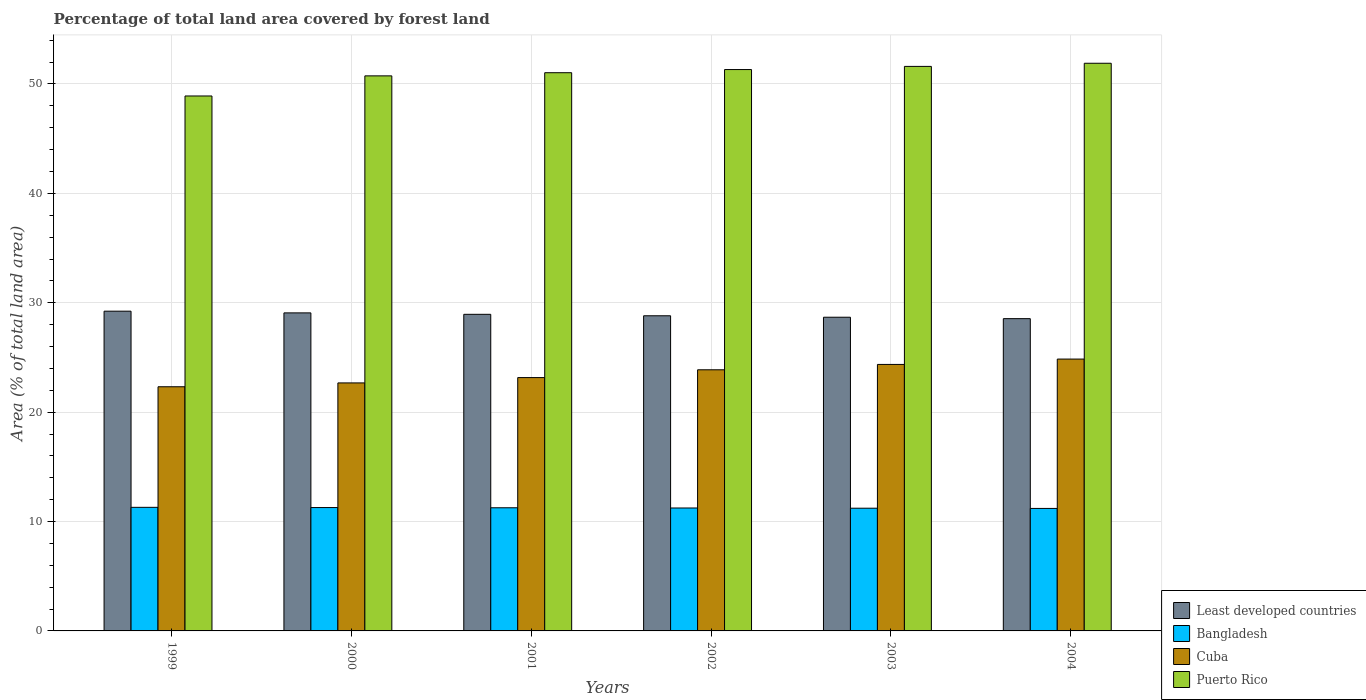Are the number of bars per tick equal to the number of legend labels?
Offer a very short reply. Yes. How many bars are there on the 4th tick from the right?
Your answer should be compact. 4. What is the percentage of forest land in Bangladesh in 2003?
Make the answer very short. 11.22. Across all years, what is the maximum percentage of forest land in Bangladesh?
Your answer should be compact. 11.3. Across all years, what is the minimum percentage of forest land in Least developed countries?
Your response must be concise. 28.55. In which year was the percentage of forest land in Bangladesh maximum?
Provide a short and direct response. 1999. In which year was the percentage of forest land in Bangladesh minimum?
Provide a short and direct response. 2004. What is the total percentage of forest land in Cuba in the graph?
Provide a short and direct response. 141.24. What is the difference between the percentage of forest land in Puerto Rico in 1999 and that in 2000?
Keep it short and to the point. -1.84. What is the difference between the percentage of forest land in Least developed countries in 2001 and the percentage of forest land in Cuba in 1999?
Your answer should be very brief. 6.62. What is the average percentage of forest land in Bangladesh per year?
Offer a terse response. 11.25. In the year 2000, what is the difference between the percentage of forest land in Bangladesh and percentage of forest land in Least developed countries?
Provide a succinct answer. -17.8. What is the ratio of the percentage of forest land in Puerto Rico in 2002 to that in 2004?
Provide a succinct answer. 0.99. Is the percentage of forest land in Puerto Rico in 1999 less than that in 2004?
Your response must be concise. Yes. What is the difference between the highest and the second highest percentage of forest land in Bangladesh?
Offer a very short reply. 0.02. What is the difference between the highest and the lowest percentage of forest land in Bangladesh?
Provide a succinct answer. 0.1. In how many years, is the percentage of forest land in Least developed countries greater than the average percentage of forest land in Least developed countries taken over all years?
Provide a succinct answer. 3. Is the sum of the percentage of forest land in Puerto Rico in 2001 and 2003 greater than the maximum percentage of forest land in Cuba across all years?
Give a very brief answer. Yes. What does the 4th bar from the left in 2004 represents?
Your answer should be very brief. Puerto Rico. What does the 3rd bar from the right in 2003 represents?
Ensure brevity in your answer.  Bangladesh. Is it the case that in every year, the sum of the percentage of forest land in Cuba and percentage of forest land in Bangladesh is greater than the percentage of forest land in Least developed countries?
Offer a terse response. Yes. How many bars are there?
Make the answer very short. 24. What is the difference between two consecutive major ticks on the Y-axis?
Your response must be concise. 10. Does the graph contain any zero values?
Provide a succinct answer. No. Where does the legend appear in the graph?
Make the answer very short. Bottom right. What is the title of the graph?
Keep it short and to the point. Percentage of total land area covered by forest land. What is the label or title of the Y-axis?
Keep it short and to the point. Area (% of total land area). What is the Area (% of total land area) of Least developed countries in 1999?
Give a very brief answer. 29.23. What is the Area (% of total land area) of Bangladesh in 1999?
Give a very brief answer. 11.3. What is the Area (% of total land area) in Cuba in 1999?
Your answer should be compact. 22.32. What is the Area (% of total land area) in Puerto Rico in 1999?
Provide a short and direct response. 48.9. What is the Area (% of total land area) in Least developed countries in 2000?
Ensure brevity in your answer.  29.08. What is the Area (% of total land area) in Bangladesh in 2000?
Your answer should be compact. 11.28. What is the Area (% of total land area) of Cuba in 2000?
Ensure brevity in your answer.  22.67. What is the Area (% of total land area) of Puerto Rico in 2000?
Make the answer very short. 50.74. What is the Area (% of total land area) of Least developed countries in 2001?
Offer a terse response. 28.94. What is the Area (% of total land area) of Bangladesh in 2001?
Give a very brief answer. 11.26. What is the Area (% of total land area) in Cuba in 2001?
Offer a terse response. 23.16. What is the Area (% of total land area) in Puerto Rico in 2001?
Keep it short and to the point. 51.03. What is the Area (% of total land area) in Least developed countries in 2002?
Ensure brevity in your answer.  28.81. What is the Area (% of total land area) in Bangladesh in 2002?
Provide a short and direct response. 11.24. What is the Area (% of total land area) in Cuba in 2002?
Your answer should be very brief. 23.87. What is the Area (% of total land area) of Puerto Rico in 2002?
Offer a terse response. 51.32. What is the Area (% of total land area) of Least developed countries in 2003?
Offer a terse response. 28.68. What is the Area (% of total land area) in Bangladesh in 2003?
Your answer should be very brief. 11.22. What is the Area (% of total land area) of Cuba in 2003?
Your response must be concise. 24.36. What is the Area (% of total land area) in Puerto Rico in 2003?
Provide a succinct answer. 51.61. What is the Area (% of total land area) in Least developed countries in 2004?
Make the answer very short. 28.55. What is the Area (% of total land area) in Bangladesh in 2004?
Keep it short and to the point. 11.2. What is the Area (% of total land area) in Cuba in 2004?
Ensure brevity in your answer.  24.85. What is the Area (% of total land area) in Puerto Rico in 2004?
Provide a short and direct response. 51.9. Across all years, what is the maximum Area (% of total land area) in Least developed countries?
Make the answer very short. 29.23. Across all years, what is the maximum Area (% of total land area) of Bangladesh?
Keep it short and to the point. 11.3. Across all years, what is the maximum Area (% of total land area) in Cuba?
Give a very brief answer. 24.85. Across all years, what is the maximum Area (% of total land area) in Puerto Rico?
Make the answer very short. 51.9. Across all years, what is the minimum Area (% of total land area) of Least developed countries?
Provide a short and direct response. 28.55. Across all years, what is the minimum Area (% of total land area) of Bangladesh?
Make the answer very short. 11.2. Across all years, what is the minimum Area (% of total land area) in Cuba?
Offer a very short reply. 22.32. Across all years, what is the minimum Area (% of total land area) in Puerto Rico?
Provide a succinct answer. 48.9. What is the total Area (% of total land area) of Least developed countries in the graph?
Your answer should be compact. 173.28. What is the total Area (% of total land area) of Bangladesh in the graph?
Provide a succinct answer. 67.49. What is the total Area (% of total land area) in Cuba in the graph?
Make the answer very short. 141.24. What is the total Area (% of total land area) in Puerto Rico in the graph?
Offer a terse response. 305.5. What is the difference between the Area (% of total land area) of Least developed countries in 1999 and that in 2000?
Offer a very short reply. 0.15. What is the difference between the Area (% of total land area) in Bangladesh in 1999 and that in 2000?
Give a very brief answer. 0.02. What is the difference between the Area (% of total land area) in Cuba in 1999 and that in 2000?
Provide a succinct answer. -0.35. What is the difference between the Area (% of total land area) of Puerto Rico in 1999 and that in 2000?
Offer a terse response. -1.84. What is the difference between the Area (% of total land area) of Least developed countries in 1999 and that in 2001?
Provide a short and direct response. 0.29. What is the difference between the Area (% of total land area) in Bangladesh in 1999 and that in 2001?
Your answer should be compact. 0.04. What is the difference between the Area (% of total land area) of Cuba in 1999 and that in 2001?
Give a very brief answer. -0.84. What is the difference between the Area (% of total land area) in Puerto Rico in 1999 and that in 2001?
Keep it short and to the point. -2.13. What is the difference between the Area (% of total land area) of Least developed countries in 1999 and that in 2002?
Keep it short and to the point. 0.42. What is the difference between the Area (% of total land area) of Bangladesh in 1999 and that in 2002?
Your answer should be compact. 0.06. What is the difference between the Area (% of total land area) in Cuba in 1999 and that in 2002?
Your answer should be very brief. -1.55. What is the difference between the Area (% of total land area) in Puerto Rico in 1999 and that in 2002?
Your response must be concise. -2.41. What is the difference between the Area (% of total land area) of Least developed countries in 1999 and that in 2003?
Your answer should be very brief. 0.55. What is the difference between the Area (% of total land area) in Bangladesh in 1999 and that in 2003?
Your answer should be very brief. 0.08. What is the difference between the Area (% of total land area) in Cuba in 1999 and that in 2003?
Offer a very short reply. -2.04. What is the difference between the Area (% of total land area) in Puerto Rico in 1999 and that in 2003?
Your answer should be very brief. -2.7. What is the difference between the Area (% of total land area) of Least developed countries in 1999 and that in 2004?
Give a very brief answer. 0.68. What is the difference between the Area (% of total land area) in Bangladesh in 1999 and that in 2004?
Provide a succinct answer. 0.1. What is the difference between the Area (% of total land area) of Cuba in 1999 and that in 2004?
Give a very brief answer. -2.53. What is the difference between the Area (% of total land area) in Puerto Rico in 1999 and that in 2004?
Give a very brief answer. -2.99. What is the difference between the Area (% of total land area) of Least developed countries in 2000 and that in 2001?
Offer a very short reply. 0.13. What is the difference between the Area (% of total land area) in Bangladesh in 2000 and that in 2001?
Make the answer very short. 0.02. What is the difference between the Area (% of total land area) of Cuba in 2000 and that in 2001?
Offer a very short reply. -0.49. What is the difference between the Area (% of total land area) of Puerto Rico in 2000 and that in 2001?
Your answer should be compact. -0.29. What is the difference between the Area (% of total land area) of Least developed countries in 2000 and that in 2002?
Give a very brief answer. 0.27. What is the difference between the Area (% of total land area) in Bangladesh in 2000 and that in 2002?
Ensure brevity in your answer.  0.04. What is the difference between the Area (% of total land area) in Cuba in 2000 and that in 2002?
Give a very brief answer. -1.2. What is the difference between the Area (% of total land area) in Puerto Rico in 2000 and that in 2002?
Provide a succinct answer. -0.58. What is the difference between the Area (% of total land area) in Least developed countries in 2000 and that in 2003?
Offer a terse response. 0.4. What is the difference between the Area (% of total land area) in Bangladesh in 2000 and that in 2003?
Your answer should be very brief. 0.06. What is the difference between the Area (% of total land area) of Cuba in 2000 and that in 2003?
Provide a succinct answer. -1.69. What is the difference between the Area (% of total land area) of Puerto Rico in 2000 and that in 2003?
Your answer should be very brief. -0.86. What is the difference between the Area (% of total land area) in Least developed countries in 2000 and that in 2004?
Ensure brevity in your answer.  0.53. What is the difference between the Area (% of total land area) in Bangladesh in 2000 and that in 2004?
Ensure brevity in your answer.  0.08. What is the difference between the Area (% of total land area) of Cuba in 2000 and that in 2004?
Make the answer very short. -2.18. What is the difference between the Area (% of total land area) of Puerto Rico in 2000 and that in 2004?
Offer a very short reply. -1.15. What is the difference between the Area (% of total land area) of Least developed countries in 2001 and that in 2002?
Your answer should be compact. 0.13. What is the difference between the Area (% of total land area) in Bangladesh in 2001 and that in 2002?
Offer a very short reply. 0.02. What is the difference between the Area (% of total land area) of Cuba in 2001 and that in 2002?
Ensure brevity in your answer.  -0.71. What is the difference between the Area (% of total land area) in Puerto Rico in 2001 and that in 2002?
Offer a very short reply. -0.29. What is the difference between the Area (% of total land area) in Least developed countries in 2001 and that in 2003?
Provide a short and direct response. 0.27. What is the difference between the Area (% of total land area) in Bangladesh in 2001 and that in 2003?
Your answer should be compact. 0.04. What is the difference between the Area (% of total land area) in Cuba in 2001 and that in 2003?
Provide a short and direct response. -1.2. What is the difference between the Area (% of total land area) of Puerto Rico in 2001 and that in 2003?
Your answer should be compact. -0.58. What is the difference between the Area (% of total land area) in Least developed countries in 2001 and that in 2004?
Give a very brief answer. 0.4. What is the difference between the Area (% of total land area) in Bangladesh in 2001 and that in 2004?
Your response must be concise. 0.06. What is the difference between the Area (% of total land area) of Cuba in 2001 and that in 2004?
Ensure brevity in your answer.  -1.69. What is the difference between the Area (% of total land area) of Puerto Rico in 2001 and that in 2004?
Provide a short and direct response. -0.86. What is the difference between the Area (% of total land area) in Least developed countries in 2002 and that in 2003?
Your answer should be very brief. 0.13. What is the difference between the Area (% of total land area) in Cuba in 2002 and that in 2003?
Give a very brief answer. -0.49. What is the difference between the Area (% of total land area) of Puerto Rico in 2002 and that in 2003?
Offer a very short reply. -0.29. What is the difference between the Area (% of total land area) in Least developed countries in 2002 and that in 2004?
Your answer should be very brief. 0.26. What is the difference between the Area (% of total land area) in Bangladesh in 2002 and that in 2004?
Keep it short and to the point. 0.04. What is the difference between the Area (% of total land area) of Cuba in 2002 and that in 2004?
Ensure brevity in your answer.  -0.98. What is the difference between the Area (% of total land area) in Puerto Rico in 2002 and that in 2004?
Keep it short and to the point. -0.58. What is the difference between the Area (% of total land area) of Least developed countries in 2003 and that in 2004?
Make the answer very short. 0.13. What is the difference between the Area (% of total land area) of Cuba in 2003 and that in 2004?
Make the answer very short. -0.49. What is the difference between the Area (% of total land area) of Puerto Rico in 2003 and that in 2004?
Offer a very short reply. -0.29. What is the difference between the Area (% of total land area) in Least developed countries in 1999 and the Area (% of total land area) in Bangladesh in 2000?
Your answer should be compact. 17.95. What is the difference between the Area (% of total land area) of Least developed countries in 1999 and the Area (% of total land area) of Cuba in 2000?
Make the answer very short. 6.56. What is the difference between the Area (% of total land area) in Least developed countries in 1999 and the Area (% of total land area) in Puerto Rico in 2000?
Ensure brevity in your answer.  -21.51. What is the difference between the Area (% of total land area) in Bangladesh in 1999 and the Area (% of total land area) in Cuba in 2000?
Make the answer very short. -11.37. What is the difference between the Area (% of total land area) in Bangladesh in 1999 and the Area (% of total land area) in Puerto Rico in 2000?
Offer a very short reply. -39.45. What is the difference between the Area (% of total land area) in Cuba in 1999 and the Area (% of total land area) in Puerto Rico in 2000?
Offer a very short reply. -28.42. What is the difference between the Area (% of total land area) in Least developed countries in 1999 and the Area (% of total land area) in Bangladesh in 2001?
Your answer should be very brief. 17.97. What is the difference between the Area (% of total land area) in Least developed countries in 1999 and the Area (% of total land area) in Cuba in 2001?
Give a very brief answer. 6.07. What is the difference between the Area (% of total land area) in Least developed countries in 1999 and the Area (% of total land area) in Puerto Rico in 2001?
Keep it short and to the point. -21.8. What is the difference between the Area (% of total land area) in Bangladesh in 1999 and the Area (% of total land area) in Cuba in 2001?
Offer a terse response. -11.86. What is the difference between the Area (% of total land area) in Bangladesh in 1999 and the Area (% of total land area) in Puerto Rico in 2001?
Your answer should be compact. -39.73. What is the difference between the Area (% of total land area) of Cuba in 1999 and the Area (% of total land area) of Puerto Rico in 2001?
Your answer should be very brief. -28.71. What is the difference between the Area (% of total land area) of Least developed countries in 1999 and the Area (% of total land area) of Bangladesh in 2002?
Your answer should be very brief. 17.99. What is the difference between the Area (% of total land area) of Least developed countries in 1999 and the Area (% of total land area) of Cuba in 2002?
Offer a terse response. 5.36. What is the difference between the Area (% of total land area) of Least developed countries in 1999 and the Area (% of total land area) of Puerto Rico in 2002?
Provide a succinct answer. -22.09. What is the difference between the Area (% of total land area) in Bangladesh in 1999 and the Area (% of total land area) in Cuba in 2002?
Your response must be concise. -12.57. What is the difference between the Area (% of total land area) in Bangladesh in 1999 and the Area (% of total land area) in Puerto Rico in 2002?
Your answer should be compact. -40.02. What is the difference between the Area (% of total land area) of Cuba in 1999 and the Area (% of total land area) of Puerto Rico in 2002?
Make the answer very short. -29. What is the difference between the Area (% of total land area) in Least developed countries in 1999 and the Area (% of total land area) in Bangladesh in 2003?
Offer a very short reply. 18.01. What is the difference between the Area (% of total land area) of Least developed countries in 1999 and the Area (% of total land area) of Cuba in 2003?
Keep it short and to the point. 4.87. What is the difference between the Area (% of total land area) in Least developed countries in 1999 and the Area (% of total land area) in Puerto Rico in 2003?
Your response must be concise. -22.38. What is the difference between the Area (% of total land area) of Bangladesh in 1999 and the Area (% of total land area) of Cuba in 2003?
Provide a succinct answer. -13.07. What is the difference between the Area (% of total land area) of Bangladesh in 1999 and the Area (% of total land area) of Puerto Rico in 2003?
Keep it short and to the point. -40.31. What is the difference between the Area (% of total land area) in Cuba in 1999 and the Area (% of total land area) in Puerto Rico in 2003?
Ensure brevity in your answer.  -29.29. What is the difference between the Area (% of total land area) of Least developed countries in 1999 and the Area (% of total land area) of Bangladesh in 2004?
Keep it short and to the point. 18.03. What is the difference between the Area (% of total land area) in Least developed countries in 1999 and the Area (% of total land area) in Cuba in 2004?
Offer a terse response. 4.38. What is the difference between the Area (% of total land area) in Least developed countries in 1999 and the Area (% of total land area) in Puerto Rico in 2004?
Provide a short and direct response. -22.67. What is the difference between the Area (% of total land area) of Bangladesh in 1999 and the Area (% of total land area) of Cuba in 2004?
Provide a short and direct response. -13.56. What is the difference between the Area (% of total land area) of Bangladesh in 1999 and the Area (% of total land area) of Puerto Rico in 2004?
Make the answer very short. -40.6. What is the difference between the Area (% of total land area) in Cuba in 1999 and the Area (% of total land area) in Puerto Rico in 2004?
Your answer should be very brief. -29.57. What is the difference between the Area (% of total land area) in Least developed countries in 2000 and the Area (% of total land area) in Bangladesh in 2001?
Your answer should be compact. 17.82. What is the difference between the Area (% of total land area) of Least developed countries in 2000 and the Area (% of total land area) of Cuba in 2001?
Give a very brief answer. 5.92. What is the difference between the Area (% of total land area) of Least developed countries in 2000 and the Area (% of total land area) of Puerto Rico in 2001?
Ensure brevity in your answer.  -21.96. What is the difference between the Area (% of total land area) of Bangladesh in 2000 and the Area (% of total land area) of Cuba in 2001?
Offer a very short reply. -11.88. What is the difference between the Area (% of total land area) of Bangladesh in 2000 and the Area (% of total land area) of Puerto Rico in 2001?
Keep it short and to the point. -39.75. What is the difference between the Area (% of total land area) in Cuba in 2000 and the Area (% of total land area) in Puerto Rico in 2001?
Make the answer very short. -28.36. What is the difference between the Area (% of total land area) of Least developed countries in 2000 and the Area (% of total land area) of Bangladesh in 2002?
Your answer should be very brief. 17.84. What is the difference between the Area (% of total land area) of Least developed countries in 2000 and the Area (% of total land area) of Cuba in 2002?
Your response must be concise. 5.2. What is the difference between the Area (% of total land area) in Least developed countries in 2000 and the Area (% of total land area) in Puerto Rico in 2002?
Offer a terse response. -22.24. What is the difference between the Area (% of total land area) of Bangladesh in 2000 and the Area (% of total land area) of Cuba in 2002?
Ensure brevity in your answer.  -12.6. What is the difference between the Area (% of total land area) in Bangladesh in 2000 and the Area (% of total land area) in Puerto Rico in 2002?
Provide a succinct answer. -40.04. What is the difference between the Area (% of total land area) of Cuba in 2000 and the Area (% of total land area) of Puerto Rico in 2002?
Provide a short and direct response. -28.65. What is the difference between the Area (% of total land area) of Least developed countries in 2000 and the Area (% of total land area) of Bangladesh in 2003?
Your answer should be compact. 17.86. What is the difference between the Area (% of total land area) in Least developed countries in 2000 and the Area (% of total land area) in Cuba in 2003?
Ensure brevity in your answer.  4.71. What is the difference between the Area (% of total land area) of Least developed countries in 2000 and the Area (% of total land area) of Puerto Rico in 2003?
Your response must be concise. -22.53. What is the difference between the Area (% of total land area) of Bangladesh in 2000 and the Area (% of total land area) of Cuba in 2003?
Offer a very short reply. -13.09. What is the difference between the Area (% of total land area) of Bangladesh in 2000 and the Area (% of total land area) of Puerto Rico in 2003?
Keep it short and to the point. -40.33. What is the difference between the Area (% of total land area) of Cuba in 2000 and the Area (% of total land area) of Puerto Rico in 2003?
Offer a terse response. -28.94. What is the difference between the Area (% of total land area) of Least developed countries in 2000 and the Area (% of total land area) of Bangladesh in 2004?
Offer a very short reply. 17.88. What is the difference between the Area (% of total land area) in Least developed countries in 2000 and the Area (% of total land area) in Cuba in 2004?
Offer a terse response. 4.22. What is the difference between the Area (% of total land area) in Least developed countries in 2000 and the Area (% of total land area) in Puerto Rico in 2004?
Your answer should be compact. -22.82. What is the difference between the Area (% of total land area) in Bangladesh in 2000 and the Area (% of total land area) in Cuba in 2004?
Give a very brief answer. -13.58. What is the difference between the Area (% of total land area) in Bangladesh in 2000 and the Area (% of total land area) in Puerto Rico in 2004?
Your response must be concise. -40.62. What is the difference between the Area (% of total land area) in Cuba in 2000 and the Area (% of total land area) in Puerto Rico in 2004?
Offer a terse response. -29.22. What is the difference between the Area (% of total land area) of Least developed countries in 2001 and the Area (% of total land area) of Bangladesh in 2002?
Your answer should be compact. 17.71. What is the difference between the Area (% of total land area) of Least developed countries in 2001 and the Area (% of total land area) of Cuba in 2002?
Ensure brevity in your answer.  5.07. What is the difference between the Area (% of total land area) in Least developed countries in 2001 and the Area (% of total land area) in Puerto Rico in 2002?
Offer a terse response. -22.38. What is the difference between the Area (% of total land area) of Bangladesh in 2001 and the Area (% of total land area) of Cuba in 2002?
Your response must be concise. -12.62. What is the difference between the Area (% of total land area) in Bangladesh in 2001 and the Area (% of total land area) in Puerto Rico in 2002?
Offer a terse response. -40.06. What is the difference between the Area (% of total land area) in Cuba in 2001 and the Area (% of total land area) in Puerto Rico in 2002?
Your response must be concise. -28.16. What is the difference between the Area (% of total land area) in Least developed countries in 2001 and the Area (% of total land area) in Bangladesh in 2003?
Offer a very short reply. 17.73. What is the difference between the Area (% of total land area) in Least developed countries in 2001 and the Area (% of total land area) in Cuba in 2003?
Offer a very short reply. 4.58. What is the difference between the Area (% of total land area) of Least developed countries in 2001 and the Area (% of total land area) of Puerto Rico in 2003?
Your answer should be compact. -22.66. What is the difference between the Area (% of total land area) of Bangladesh in 2001 and the Area (% of total land area) of Cuba in 2003?
Ensure brevity in your answer.  -13.11. What is the difference between the Area (% of total land area) in Bangladesh in 2001 and the Area (% of total land area) in Puerto Rico in 2003?
Offer a terse response. -40.35. What is the difference between the Area (% of total land area) in Cuba in 2001 and the Area (% of total land area) in Puerto Rico in 2003?
Your answer should be compact. -28.45. What is the difference between the Area (% of total land area) of Least developed countries in 2001 and the Area (% of total land area) of Bangladesh in 2004?
Provide a short and direct response. 17.75. What is the difference between the Area (% of total land area) in Least developed countries in 2001 and the Area (% of total land area) in Cuba in 2004?
Ensure brevity in your answer.  4.09. What is the difference between the Area (% of total land area) in Least developed countries in 2001 and the Area (% of total land area) in Puerto Rico in 2004?
Make the answer very short. -22.95. What is the difference between the Area (% of total land area) in Bangladesh in 2001 and the Area (% of total land area) in Cuba in 2004?
Keep it short and to the point. -13.6. What is the difference between the Area (% of total land area) of Bangladesh in 2001 and the Area (% of total land area) of Puerto Rico in 2004?
Give a very brief answer. -40.64. What is the difference between the Area (% of total land area) in Cuba in 2001 and the Area (% of total land area) in Puerto Rico in 2004?
Provide a short and direct response. -28.73. What is the difference between the Area (% of total land area) of Least developed countries in 2002 and the Area (% of total land area) of Bangladesh in 2003?
Your response must be concise. 17.59. What is the difference between the Area (% of total land area) of Least developed countries in 2002 and the Area (% of total land area) of Cuba in 2003?
Keep it short and to the point. 4.45. What is the difference between the Area (% of total land area) of Least developed countries in 2002 and the Area (% of total land area) of Puerto Rico in 2003?
Provide a succinct answer. -22.8. What is the difference between the Area (% of total land area) of Bangladesh in 2002 and the Area (% of total land area) of Cuba in 2003?
Offer a very short reply. -13.13. What is the difference between the Area (% of total land area) in Bangladesh in 2002 and the Area (% of total land area) in Puerto Rico in 2003?
Your answer should be compact. -40.37. What is the difference between the Area (% of total land area) of Cuba in 2002 and the Area (% of total land area) of Puerto Rico in 2003?
Offer a very short reply. -27.74. What is the difference between the Area (% of total land area) in Least developed countries in 2002 and the Area (% of total land area) in Bangladesh in 2004?
Provide a succinct answer. 17.61. What is the difference between the Area (% of total land area) in Least developed countries in 2002 and the Area (% of total land area) in Cuba in 2004?
Offer a very short reply. 3.96. What is the difference between the Area (% of total land area) in Least developed countries in 2002 and the Area (% of total land area) in Puerto Rico in 2004?
Offer a terse response. -23.09. What is the difference between the Area (% of total land area) of Bangladesh in 2002 and the Area (% of total land area) of Cuba in 2004?
Ensure brevity in your answer.  -13.62. What is the difference between the Area (% of total land area) of Bangladesh in 2002 and the Area (% of total land area) of Puerto Rico in 2004?
Ensure brevity in your answer.  -40.66. What is the difference between the Area (% of total land area) of Cuba in 2002 and the Area (% of total land area) of Puerto Rico in 2004?
Offer a terse response. -28.02. What is the difference between the Area (% of total land area) of Least developed countries in 2003 and the Area (% of total land area) of Bangladesh in 2004?
Your answer should be very brief. 17.48. What is the difference between the Area (% of total land area) in Least developed countries in 2003 and the Area (% of total land area) in Cuba in 2004?
Give a very brief answer. 3.82. What is the difference between the Area (% of total land area) of Least developed countries in 2003 and the Area (% of total land area) of Puerto Rico in 2004?
Your answer should be compact. -23.22. What is the difference between the Area (% of total land area) of Bangladesh in 2003 and the Area (% of total land area) of Cuba in 2004?
Ensure brevity in your answer.  -13.64. What is the difference between the Area (% of total land area) of Bangladesh in 2003 and the Area (% of total land area) of Puerto Rico in 2004?
Your answer should be compact. -40.68. What is the difference between the Area (% of total land area) in Cuba in 2003 and the Area (% of total land area) in Puerto Rico in 2004?
Keep it short and to the point. -27.53. What is the average Area (% of total land area) in Least developed countries per year?
Provide a succinct answer. 28.88. What is the average Area (% of total land area) of Bangladesh per year?
Offer a terse response. 11.25. What is the average Area (% of total land area) of Cuba per year?
Provide a short and direct response. 23.54. What is the average Area (% of total land area) of Puerto Rico per year?
Make the answer very short. 50.92. In the year 1999, what is the difference between the Area (% of total land area) in Least developed countries and Area (% of total land area) in Bangladesh?
Provide a short and direct response. 17.93. In the year 1999, what is the difference between the Area (% of total land area) in Least developed countries and Area (% of total land area) in Cuba?
Give a very brief answer. 6.91. In the year 1999, what is the difference between the Area (% of total land area) in Least developed countries and Area (% of total land area) in Puerto Rico?
Ensure brevity in your answer.  -19.67. In the year 1999, what is the difference between the Area (% of total land area) in Bangladesh and Area (% of total land area) in Cuba?
Offer a very short reply. -11.02. In the year 1999, what is the difference between the Area (% of total land area) of Bangladesh and Area (% of total land area) of Puerto Rico?
Offer a very short reply. -37.61. In the year 1999, what is the difference between the Area (% of total land area) of Cuba and Area (% of total land area) of Puerto Rico?
Your answer should be compact. -26.58. In the year 2000, what is the difference between the Area (% of total land area) in Least developed countries and Area (% of total land area) in Bangladesh?
Offer a terse response. 17.8. In the year 2000, what is the difference between the Area (% of total land area) in Least developed countries and Area (% of total land area) in Cuba?
Ensure brevity in your answer.  6.4. In the year 2000, what is the difference between the Area (% of total land area) in Least developed countries and Area (% of total land area) in Puerto Rico?
Provide a short and direct response. -21.67. In the year 2000, what is the difference between the Area (% of total land area) in Bangladesh and Area (% of total land area) in Cuba?
Keep it short and to the point. -11.39. In the year 2000, what is the difference between the Area (% of total land area) of Bangladesh and Area (% of total land area) of Puerto Rico?
Provide a short and direct response. -39.47. In the year 2000, what is the difference between the Area (% of total land area) in Cuba and Area (% of total land area) in Puerto Rico?
Give a very brief answer. -28.07. In the year 2001, what is the difference between the Area (% of total land area) of Least developed countries and Area (% of total land area) of Bangladesh?
Offer a terse response. 17.69. In the year 2001, what is the difference between the Area (% of total land area) of Least developed countries and Area (% of total land area) of Cuba?
Ensure brevity in your answer.  5.78. In the year 2001, what is the difference between the Area (% of total land area) of Least developed countries and Area (% of total land area) of Puerto Rico?
Give a very brief answer. -22.09. In the year 2001, what is the difference between the Area (% of total land area) in Bangladesh and Area (% of total land area) in Cuba?
Your answer should be very brief. -11.9. In the year 2001, what is the difference between the Area (% of total land area) in Bangladesh and Area (% of total land area) in Puerto Rico?
Offer a very short reply. -39.77. In the year 2001, what is the difference between the Area (% of total land area) in Cuba and Area (% of total land area) in Puerto Rico?
Your response must be concise. -27.87. In the year 2002, what is the difference between the Area (% of total land area) in Least developed countries and Area (% of total land area) in Bangladesh?
Provide a succinct answer. 17.57. In the year 2002, what is the difference between the Area (% of total land area) in Least developed countries and Area (% of total land area) in Cuba?
Your answer should be compact. 4.94. In the year 2002, what is the difference between the Area (% of total land area) of Least developed countries and Area (% of total land area) of Puerto Rico?
Offer a very short reply. -22.51. In the year 2002, what is the difference between the Area (% of total land area) of Bangladesh and Area (% of total land area) of Cuba?
Provide a succinct answer. -12.63. In the year 2002, what is the difference between the Area (% of total land area) of Bangladesh and Area (% of total land area) of Puerto Rico?
Ensure brevity in your answer.  -40.08. In the year 2002, what is the difference between the Area (% of total land area) in Cuba and Area (% of total land area) in Puerto Rico?
Provide a succinct answer. -27.45. In the year 2003, what is the difference between the Area (% of total land area) in Least developed countries and Area (% of total land area) in Bangladesh?
Provide a short and direct response. 17.46. In the year 2003, what is the difference between the Area (% of total land area) of Least developed countries and Area (% of total land area) of Cuba?
Your response must be concise. 4.31. In the year 2003, what is the difference between the Area (% of total land area) of Least developed countries and Area (% of total land area) of Puerto Rico?
Offer a very short reply. -22.93. In the year 2003, what is the difference between the Area (% of total land area) in Bangladesh and Area (% of total land area) in Cuba?
Offer a terse response. -13.15. In the year 2003, what is the difference between the Area (% of total land area) in Bangladesh and Area (% of total land area) in Puerto Rico?
Provide a short and direct response. -40.39. In the year 2003, what is the difference between the Area (% of total land area) of Cuba and Area (% of total land area) of Puerto Rico?
Your answer should be compact. -27.24. In the year 2004, what is the difference between the Area (% of total land area) of Least developed countries and Area (% of total land area) of Bangladesh?
Provide a succinct answer. 17.35. In the year 2004, what is the difference between the Area (% of total land area) in Least developed countries and Area (% of total land area) in Cuba?
Offer a very short reply. 3.69. In the year 2004, what is the difference between the Area (% of total land area) of Least developed countries and Area (% of total land area) of Puerto Rico?
Provide a succinct answer. -23.35. In the year 2004, what is the difference between the Area (% of total land area) of Bangladesh and Area (% of total land area) of Cuba?
Your answer should be very brief. -13.66. In the year 2004, what is the difference between the Area (% of total land area) in Bangladesh and Area (% of total land area) in Puerto Rico?
Ensure brevity in your answer.  -40.7. In the year 2004, what is the difference between the Area (% of total land area) of Cuba and Area (% of total land area) of Puerto Rico?
Give a very brief answer. -27.04. What is the ratio of the Area (% of total land area) of Cuba in 1999 to that in 2000?
Provide a succinct answer. 0.98. What is the ratio of the Area (% of total land area) of Puerto Rico in 1999 to that in 2000?
Make the answer very short. 0.96. What is the ratio of the Area (% of total land area) of Least developed countries in 1999 to that in 2001?
Your answer should be very brief. 1.01. What is the ratio of the Area (% of total land area) in Cuba in 1999 to that in 2001?
Provide a succinct answer. 0.96. What is the ratio of the Area (% of total land area) of Puerto Rico in 1999 to that in 2001?
Ensure brevity in your answer.  0.96. What is the ratio of the Area (% of total land area) in Least developed countries in 1999 to that in 2002?
Ensure brevity in your answer.  1.01. What is the ratio of the Area (% of total land area) of Bangladesh in 1999 to that in 2002?
Your answer should be very brief. 1.01. What is the ratio of the Area (% of total land area) of Cuba in 1999 to that in 2002?
Offer a very short reply. 0.94. What is the ratio of the Area (% of total land area) of Puerto Rico in 1999 to that in 2002?
Make the answer very short. 0.95. What is the ratio of the Area (% of total land area) in Least developed countries in 1999 to that in 2003?
Offer a very short reply. 1.02. What is the ratio of the Area (% of total land area) of Bangladesh in 1999 to that in 2003?
Keep it short and to the point. 1.01. What is the ratio of the Area (% of total land area) of Cuba in 1999 to that in 2003?
Give a very brief answer. 0.92. What is the ratio of the Area (% of total land area) of Puerto Rico in 1999 to that in 2003?
Provide a succinct answer. 0.95. What is the ratio of the Area (% of total land area) in Least developed countries in 1999 to that in 2004?
Offer a terse response. 1.02. What is the ratio of the Area (% of total land area) in Bangladesh in 1999 to that in 2004?
Make the answer very short. 1.01. What is the ratio of the Area (% of total land area) of Cuba in 1999 to that in 2004?
Keep it short and to the point. 0.9. What is the ratio of the Area (% of total land area) of Puerto Rico in 1999 to that in 2004?
Ensure brevity in your answer.  0.94. What is the ratio of the Area (% of total land area) in Cuba in 2000 to that in 2001?
Ensure brevity in your answer.  0.98. What is the ratio of the Area (% of total land area) in Least developed countries in 2000 to that in 2002?
Your answer should be compact. 1.01. What is the ratio of the Area (% of total land area) in Bangladesh in 2000 to that in 2002?
Offer a terse response. 1. What is the ratio of the Area (% of total land area) in Cuba in 2000 to that in 2002?
Your response must be concise. 0.95. What is the ratio of the Area (% of total land area) of Least developed countries in 2000 to that in 2003?
Give a very brief answer. 1.01. What is the ratio of the Area (% of total land area) in Cuba in 2000 to that in 2003?
Provide a short and direct response. 0.93. What is the ratio of the Area (% of total land area) of Puerto Rico in 2000 to that in 2003?
Offer a very short reply. 0.98. What is the ratio of the Area (% of total land area) of Least developed countries in 2000 to that in 2004?
Your answer should be very brief. 1.02. What is the ratio of the Area (% of total land area) in Bangladesh in 2000 to that in 2004?
Offer a very short reply. 1.01. What is the ratio of the Area (% of total land area) in Cuba in 2000 to that in 2004?
Make the answer very short. 0.91. What is the ratio of the Area (% of total land area) in Puerto Rico in 2000 to that in 2004?
Keep it short and to the point. 0.98. What is the ratio of the Area (% of total land area) of Least developed countries in 2001 to that in 2002?
Your response must be concise. 1. What is the ratio of the Area (% of total land area) in Cuba in 2001 to that in 2002?
Provide a succinct answer. 0.97. What is the ratio of the Area (% of total land area) of Least developed countries in 2001 to that in 2003?
Provide a short and direct response. 1.01. What is the ratio of the Area (% of total land area) of Cuba in 2001 to that in 2003?
Offer a terse response. 0.95. What is the ratio of the Area (% of total land area) of Puerto Rico in 2001 to that in 2003?
Offer a very short reply. 0.99. What is the ratio of the Area (% of total land area) in Least developed countries in 2001 to that in 2004?
Offer a terse response. 1.01. What is the ratio of the Area (% of total land area) of Bangladesh in 2001 to that in 2004?
Provide a short and direct response. 1.01. What is the ratio of the Area (% of total land area) of Cuba in 2001 to that in 2004?
Your response must be concise. 0.93. What is the ratio of the Area (% of total land area) of Puerto Rico in 2001 to that in 2004?
Your answer should be compact. 0.98. What is the ratio of the Area (% of total land area) of Cuba in 2002 to that in 2003?
Offer a very short reply. 0.98. What is the ratio of the Area (% of total land area) of Least developed countries in 2002 to that in 2004?
Keep it short and to the point. 1.01. What is the ratio of the Area (% of total land area) of Cuba in 2002 to that in 2004?
Your answer should be very brief. 0.96. What is the ratio of the Area (% of total land area) of Puerto Rico in 2002 to that in 2004?
Provide a short and direct response. 0.99. What is the ratio of the Area (% of total land area) in Bangladesh in 2003 to that in 2004?
Make the answer very short. 1. What is the ratio of the Area (% of total land area) of Cuba in 2003 to that in 2004?
Offer a very short reply. 0.98. What is the ratio of the Area (% of total land area) in Puerto Rico in 2003 to that in 2004?
Your answer should be very brief. 0.99. What is the difference between the highest and the second highest Area (% of total land area) of Least developed countries?
Offer a very short reply. 0.15. What is the difference between the highest and the second highest Area (% of total land area) in Cuba?
Your answer should be very brief. 0.49. What is the difference between the highest and the second highest Area (% of total land area) of Puerto Rico?
Keep it short and to the point. 0.29. What is the difference between the highest and the lowest Area (% of total land area) in Least developed countries?
Keep it short and to the point. 0.68. What is the difference between the highest and the lowest Area (% of total land area) in Bangladesh?
Your answer should be very brief. 0.1. What is the difference between the highest and the lowest Area (% of total land area) in Cuba?
Provide a short and direct response. 2.53. What is the difference between the highest and the lowest Area (% of total land area) in Puerto Rico?
Your answer should be compact. 2.99. 